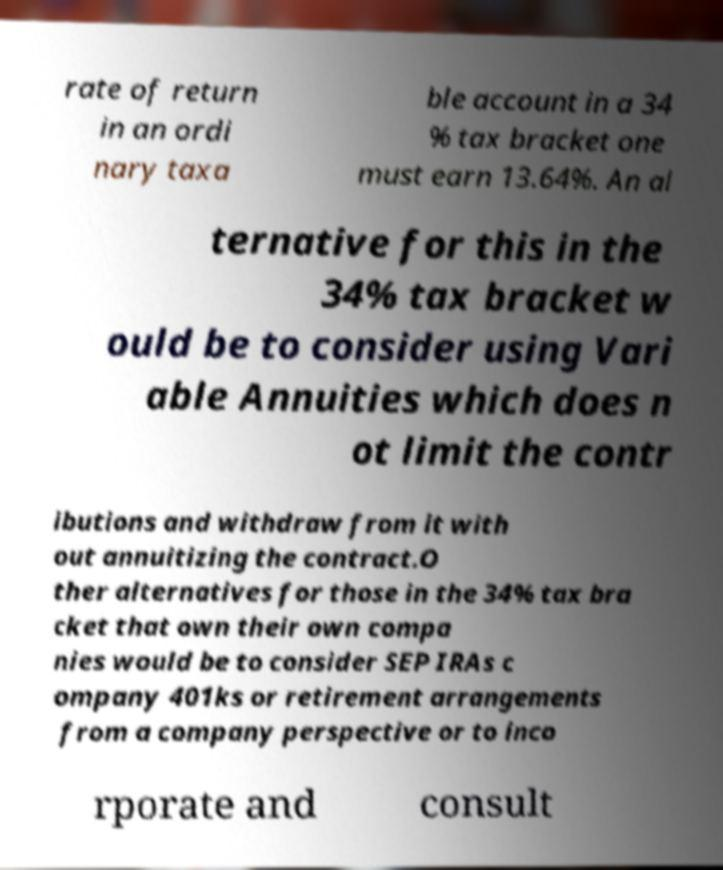For documentation purposes, I need the text within this image transcribed. Could you provide that? rate of return in an ordi nary taxa ble account in a 34 % tax bracket one must earn 13.64%. An al ternative for this in the 34% tax bracket w ould be to consider using Vari able Annuities which does n ot limit the contr ibutions and withdraw from it with out annuitizing the contract.O ther alternatives for those in the 34% tax bra cket that own their own compa nies would be to consider SEP IRAs c ompany 401ks or retirement arrangements from a company perspective or to inco rporate and consult 